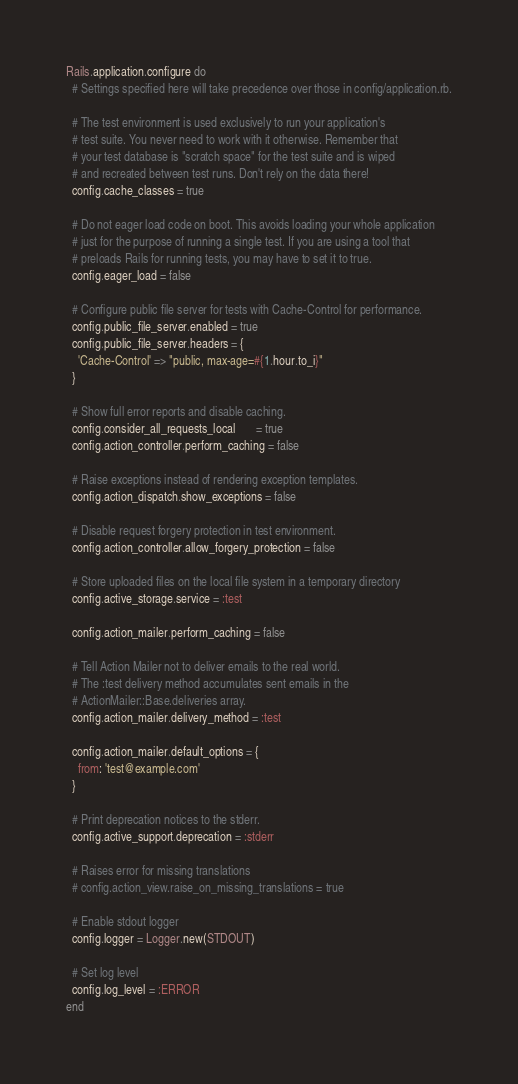<code> <loc_0><loc_0><loc_500><loc_500><_Ruby_>Rails.application.configure do
  # Settings specified here will take precedence over those in config/application.rb.

  # The test environment is used exclusively to run your application's
  # test suite. You never need to work with it otherwise. Remember that
  # your test database is "scratch space" for the test suite and is wiped
  # and recreated between test runs. Don't rely on the data there!
  config.cache_classes = true

  # Do not eager load code on boot. This avoids loading your whole application
  # just for the purpose of running a single test. If you are using a tool that
  # preloads Rails for running tests, you may have to set it to true.
  config.eager_load = false

  # Configure public file server for tests with Cache-Control for performance.
  config.public_file_server.enabled = true
  config.public_file_server.headers = {
    'Cache-Control' => "public, max-age=#{1.hour.to_i}"
  }

  # Show full error reports and disable caching.
  config.consider_all_requests_local       = true
  config.action_controller.perform_caching = false

  # Raise exceptions instead of rendering exception templates.
  config.action_dispatch.show_exceptions = false

  # Disable request forgery protection in test environment.
  config.action_controller.allow_forgery_protection = false

  # Store uploaded files on the local file system in a temporary directory
  config.active_storage.service = :test

  config.action_mailer.perform_caching = false

  # Tell Action Mailer not to deliver emails to the real world.
  # The :test delivery method accumulates sent emails in the
  # ActionMailer::Base.deliveries array.
  config.action_mailer.delivery_method = :test

  config.action_mailer.default_options = {
    from: 'test@example.com'
  }

  # Print deprecation notices to the stderr.
  config.active_support.deprecation = :stderr

  # Raises error for missing translations
  # config.action_view.raise_on_missing_translations = true

  # Enable stdout logger
  config.logger = Logger.new(STDOUT)

  # Set log level
  config.log_level = :ERROR
end
</code> 